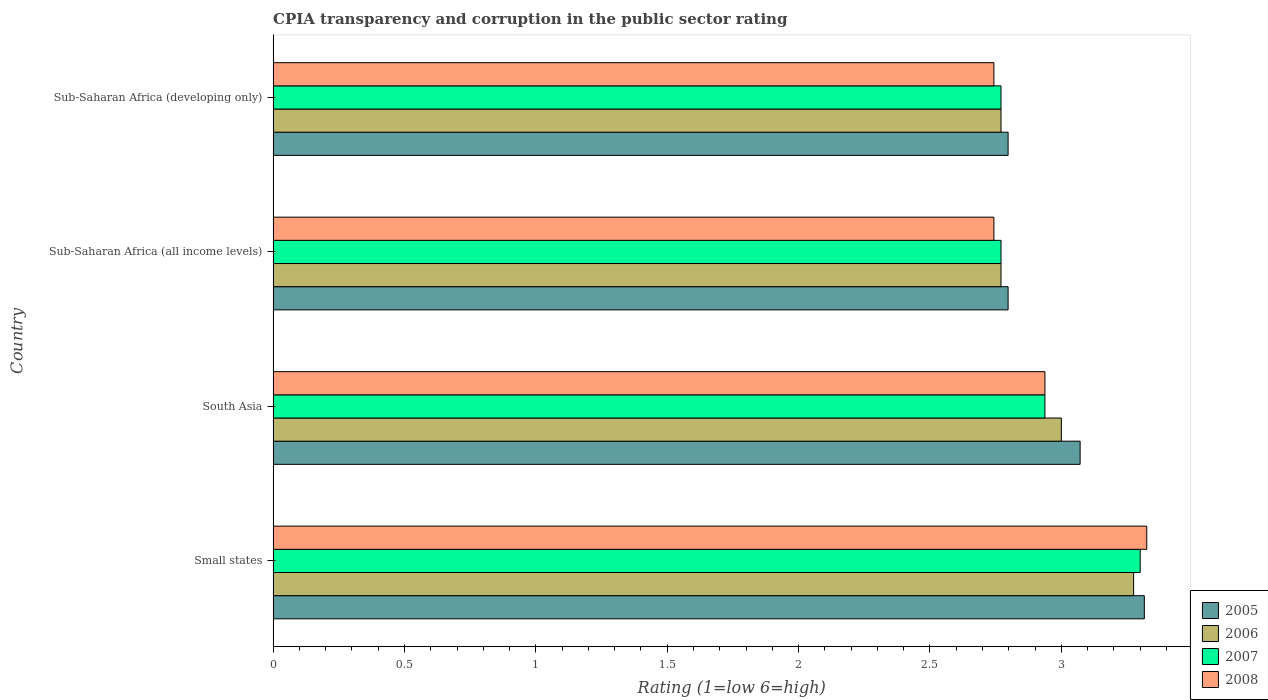Are the number of bars per tick equal to the number of legend labels?
Your answer should be very brief. Yes. How many bars are there on the 1st tick from the top?
Keep it short and to the point. 4. How many bars are there on the 3rd tick from the bottom?
Keep it short and to the point. 4. In how many cases, is the number of bars for a given country not equal to the number of legend labels?
Ensure brevity in your answer.  0. What is the CPIA rating in 2008 in Sub-Saharan Africa (developing only)?
Keep it short and to the point. 2.74. Across all countries, what is the minimum CPIA rating in 2007?
Provide a succinct answer. 2.77. In which country was the CPIA rating in 2005 maximum?
Your answer should be compact. Small states. In which country was the CPIA rating in 2008 minimum?
Ensure brevity in your answer.  Sub-Saharan Africa (all income levels). What is the total CPIA rating in 2005 in the graph?
Keep it short and to the point. 11.98. What is the difference between the CPIA rating in 2007 in Small states and that in Sub-Saharan Africa (all income levels)?
Provide a succinct answer. 0.53. What is the difference between the CPIA rating in 2006 in Sub-Saharan Africa (developing only) and the CPIA rating in 2007 in Small states?
Your answer should be very brief. -0.53. What is the average CPIA rating in 2008 per country?
Your answer should be compact. 2.94. What is the difference between the CPIA rating in 2007 and CPIA rating in 2005 in Sub-Saharan Africa (all income levels)?
Provide a short and direct response. -0.03. In how many countries, is the CPIA rating in 2005 greater than 3 ?
Make the answer very short. 2. What is the ratio of the CPIA rating in 2005 in South Asia to that in Sub-Saharan Africa (all income levels)?
Make the answer very short. 1.1. Is the CPIA rating in 2007 in Small states less than that in Sub-Saharan Africa (all income levels)?
Give a very brief answer. No. What is the difference between the highest and the second highest CPIA rating in 2007?
Offer a very short reply. 0.36. What is the difference between the highest and the lowest CPIA rating in 2007?
Keep it short and to the point. 0.53. In how many countries, is the CPIA rating in 2007 greater than the average CPIA rating in 2007 taken over all countries?
Provide a succinct answer. 1. Is the sum of the CPIA rating in 2005 in South Asia and Sub-Saharan Africa (developing only) greater than the maximum CPIA rating in 2007 across all countries?
Keep it short and to the point. Yes. Is it the case that in every country, the sum of the CPIA rating in 2007 and CPIA rating in 2008 is greater than the sum of CPIA rating in 2006 and CPIA rating in 2005?
Keep it short and to the point. No. What does the 3rd bar from the top in Sub-Saharan Africa (developing only) represents?
Your response must be concise. 2006. What does the 4th bar from the bottom in Small states represents?
Provide a succinct answer. 2008. Are all the bars in the graph horizontal?
Provide a succinct answer. Yes. How many countries are there in the graph?
Provide a short and direct response. 4. What is the difference between two consecutive major ticks on the X-axis?
Keep it short and to the point. 0.5. Where does the legend appear in the graph?
Your answer should be very brief. Bottom right. How many legend labels are there?
Ensure brevity in your answer.  4. What is the title of the graph?
Offer a terse response. CPIA transparency and corruption in the public sector rating. What is the Rating (1=low 6=high) of 2005 in Small states?
Offer a very short reply. 3.32. What is the Rating (1=low 6=high) in 2006 in Small states?
Your answer should be very brief. 3.27. What is the Rating (1=low 6=high) in 2007 in Small states?
Make the answer very short. 3.3. What is the Rating (1=low 6=high) of 2008 in Small states?
Your answer should be compact. 3.33. What is the Rating (1=low 6=high) in 2005 in South Asia?
Provide a short and direct response. 3.07. What is the Rating (1=low 6=high) in 2006 in South Asia?
Your answer should be very brief. 3. What is the Rating (1=low 6=high) in 2007 in South Asia?
Your response must be concise. 2.94. What is the Rating (1=low 6=high) of 2008 in South Asia?
Your answer should be very brief. 2.94. What is the Rating (1=low 6=high) of 2005 in Sub-Saharan Africa (all income levels)?
Give a very brief answer. 2.8. What is the Rating (1=low 6=high) of 2006 in Sub-Saharan Africa (all income levels)?
Your answer should be very brief. 2.77. What is the Rating (1=low 6=high) in 2007 in Sub-Saharan Africa (all income levels)?
Ensure brevity in your answer.  2.77. What is the Rating (1=low 6=high) of 2008 in Sub-Saharan Africa (all income levels)?
Keep it short and to the point. 2.74. What is the Rating (1=low 6=high) of 2005 in Sub-Saharan Africa (developing only)?
Ensure brevity in your answer.  2.8. What is the Rating (1=low 6=high) of 2006 in Sub-Saharan Africa (developing only)?
Ensure brevity in your answer.  2.77. What is the Rating (1=low 6=high) of 2007 in Sub-Saharan Africa (developing only)?
Give a very brief answer. 2.77. What is the Rating (1=low 6=high) of 2008 in Sub-Saharan Africa (developing only)?
Offer a terse response. 2.74. Across all countries, what is the maximum Rating (1=low 6=high) in 2005?
Keep it short and to the point. 3.32. Across all countries, what is the maximum Rating (1=low 6=high) in 2006?
Keep it short and to the point. 3.27. Across all countries, what is the maximum Rating (1=low 6=high) of 2008?
Provide a short and direct response. 3.33. Across all countries, what is the minimum Rating (1=low 6=high) of 2005?
Your response must be concise. 2.8. Across all countries, what is the minimum Rating (1=low 6=high) in 2006?
Offer a terse response. 2.77. Across all countries, what is the minimum Rating (1=low 6=high) of 2007?
Offer a very short reply. 2.77. Across all countries, what is the minimum Rating (1=low 6=high) in 2008?
Give a very brief answer. 2.74. What is the total Rating (1=low 6=high) in 2005 in the graph?
Your answer should be compact. 11.98. What is the total Rating (1=low 6=high) in 2006 in the graph?
Your answer should be very brief. 11.82. What is the total Rating (1=low 6=high) in 2007 in the graph?
Offer a very short reply. 11.78. What is the total Rating (1=low 6=high) in 2008 in the graph?
Keep it short and to the point. 11.75. What is the difference between the Rating (1=low 6=high) of 2005 in Small states and that in South Asia?
Keep it short and to the point. 0.24. What is the difference between the Rating (1=low 6=high) of 2006 in Small states and that in South Asia?
Provide a succinct answer. 0.28. What is the difference between the Rating (1=low 6=high) in 2007 in Small states and that in South Asia?
Keep it short and to the point. 0.36. What is the difference between the Rating (1=low 6=high) of 2008 in Small states and that in South Asia?
Your answer should be compact. 0.39. What is the difference between the Rating (1=low 6=high) in 2005 in Small states and that in Sub-Saharan Africa (all income levels)?
Your response must be concise. 0.52. What is the difference between the Rating (1=low 6=high) of 2006 in Small states and that in Sub-Saharan Africa (all income levels)?
Give a very brief answer. 0.5. What is the difference between the Rating (1=low 6=high) of 2007 in Small states and that in Sub-Saharan Africa (all income levels)?
Provide a succinct answer. 0.53. What is the difference between the Rating (1=low 6=high) in 2008 in Small states and that in Sub-Saharan Africa (all income levels)?
Offer a very short reply. 0.58. What is the difference between the Rating (1=low 6=high) of 2005 in Small states and that in Sub-Saharan Africa (developing only)?
Provide a succinct answer. 0.52. What is the difference between the Rating (1=low 6=high) in 2006 in Small states and that in Sub-Saharan Africa (developing only)?
Provide a succinct answer. 0.5. What is the difference between the Rating (1=low 6=high) of 2007 in Small states and that in Sub-Saharan Africa (developing only)?
Give a very brief answer. 0.53. What is the difference between the Rating (1=low 6=high) of 2008 in Small states and that in Sub-Saharan Africa (developing only)?
Make the answer very short. 0.58. What is the difference between the Rating (1=low 6=high) of 2005 in South Asia and that in Sub-Saharan Africa (all income levels)?
Your answer should be compact. 0.27. What is the difference between the Rating (1=low 6=high) in 2006 in South Asia and that in Sub-Saharan Africa (all income levels)?
Offer a very short reply. 0.23. What is the difference between the Rating (1=low 6=high) in 2007 in South Asia and that in Sub-Saharan Africa (all income levels)?
Make the answer very short. 0.17. What is the difference between the Rating (1=low 6=high) of 2008 in South Asia and that in Sub-Saharan Africa (all income levels)?
Make the answer very short. 0.19. What is the difference between the Rating (1=low 6=high) in 2005 in South Asia and that in Sub-Saharan Africa (developing only)?
Your answer should be very brief. 0.27. What is the difference between the Rating (1=low 6=high) in 2006 in South Asia and that in Sub-Saharan Africa (developing only)?
Ensure brevity in your answer.  0.23. What is the difference between the Rating (1=low 6=high) in 2007 in South Asia and that in Sub-Saharan Africa (developing only)?
Ensure brevity in your answer.  0.17. What is the difference between the Rating (1=low 6=high) in 2008 in South Asia and that in Sub-Saharan Africa (developing only)?
Ensure brevity in your answer.  0.19. What is the difference between the Rating (1=low 6=high) in 2005 in Sub-Saharan Africa (all income levels) and that in Sub-Saharan Africa (developing only)?
Offer a terse response. 0. What is the difference between the Rating (1=low 6=high) of 2006 in Sub-Saharan Africa (all income levels) and that in Sub-Saharan Africa (developing only)?
Your answer should be compact. 0. What is the difference between the Rating (1=low 6=high) in 2007 in Sub-Saharan Africa (all income levels) and that in Sub-Saharan Africa (developing only)?
Your answer should be compact. 0. What is the difference between the Rating (1=low 6=high) of 2005 in Small states and the Rating (1=low 6=high) of 2006 in South Asia?
Offer a terse response. 0.32. What is the difference between the Rating (1=low 6=high) in 2005 in Small states and the Rating (1=low 6=high) in 2007 in South Asia?
Ensure brevity in your answer.  0.38. What is the difference between the Rating (1=low 6=high) of 2005 in Small states and the Rating (1=low 6=high) of 2008 in South Asia?
Keep it short and to the point. 0.38. What is the difference between the Rating (1=low 6=high) in 2006 in Small states and the Rating (1=low 6=high) in 2007 in South Asia?
Offer a terse response. 0.34. What is the difference between the Rating (1=low 6=high) of 2006 in Small states and the Rating (1=low 6=high) of 2008 in South Asia?
Your answer should be very brief. 0.34. What is the difference between the Rating (1=low 6=high) of 2007 in Small states and the Rating (1=low 6=high) of 2008 in South Asia?
Your response must be concise. 0.36. What is the difference between the Rating (1=low 6=high) of 2005 in Small states and the Rating (1=low 6=high) of 2006 in Sub-Saharan Africa (all income levels)?
Ensure brevity in your answer.  0.55. What is the difference between the Rating (1=low 6=high) of 2005 in Small states and the Rating (1=low 6=high) of 2007 in Sub-Saharan Africa (all income levels)?
Your answer should be compact. 0.55. What is the difference between the Rating (1=low 6=high) in 2005 in Small states and the Rating (1=low 6=high) in 2008 in Sub-Saharan Africa (all income levels)?
Make the answer very short. 0.57. What is the difference between the Rating (1=low 6=high) in 2006 in Small states and the Rating (1=low 6=high) in 2007 in Sub-Saharan Africa (all income levels)?
Provide a succinct answer. 0.5. What is the difference between the Rating (1=low 6=high) of 2006 in Small states and the Rating (1=low 6=high) of 2008 in Sub-Saharan Africa (all income levels)?
Keep it short and to the point. 0.53. What is the difference between the Rating (1=low 6=high) of 2007 in Small states and the Rating (1=low 6=high) of 2008 in Sub-Saharan Africa (all income levels)?
Offer a terse response. 0.56. What is the difference between the Rating (1=low 6=high) in 2005 in Small states and the Rating (1=low 6=high) in 2006 in Sub-Saharan Africa (developing only)?
Your response must be concise. 0.55. What is the difference between the Rating (1=low 6=high) of 2005 in Small states and the Rating (1=low 6=high) of 2007 in Sub-Saharan Africa (developing only)?
Your answer should be compact. 0.55. What is the difference between the Rating (1=low 6=high) in 2005 in Small states and the Rating (1=low 6=high) in 2008 in Sub-Saharan Africa (developing only)?
Your answer should be compact. 0.57. What is the difference between the Rating (1=low 6=high) in 2006 in Small states and the Rating (1=low 6=high) in 2007 in Sub-Saharan Africa (developing only)?
Keep it short and to the point. 0.5. What is the difference between the Rating (1=low 6=high) of 2006 in Small states and the Rating (1=low 6=high) of 2008 in Sub-Saharan Africa (developing only)?
Keep it short and to the point. 0.53. What is the difference between the Rating (1=low 6=high) in 2007 in Small states and the Rating (1=low 6=high) in 2008 in Sub-Saharan Africa (developing only)?
Give a very brief answer. 0.56. What is the difference between the Rating (1=low 6=high) of 2005 in South Asia and the Rating (1=low 6=high) of 2006 in Sub-Saharan Africa (all income levels)?
Keep it short and to the point. 0.3. What is the difference between the Rating (1=low 6=high) in 2005 in South Asia and the Rating (1=low 6=high) in 2007 in Sub-Saharan Africa (all income levels)?
Provide a succinct answer. 0.3. What is the difference between the Rating (1=low 6=high) of 2005 in South Asia and the Rating (1=low 6=high) of 2008 in Sub-Saharan Africa (all income levels)?
Your response must be concise. 0.33. What is the difference between the Rating (1=low 6=high) in 2006 in South Asia and the Rating (1=low 6=high) in 2007 in Sub-Saharan Africa (all income levels)?
Your answer should be very brief. 0.23. What is the difference between the Rating (1=low 6=high) in 2006 in South Asia and the Rating (1=low 6=high) in 2008 in Sub-Saharan Africa (all income levels)?
Your answer should be compact. 0.26. What is the difference between the Rating (1=low 6=high) in 2007 in South Asia and the Rating (1=low 6=high) in 2008 in Sub-Saharan Africa (all income levels)?
Ensure brevity in your answer.  0.19. What is the difference between the Rating (1=low 6=high) in 2005 in South Asia and the Rating (1=low 6=high) in 2006 in Sub-Saharan Africa (developing only)?
Provide a succinct answer. 0.3. What is the difference between the Rating (1=low 6=high) of 2005 in South Asia and the Rating (1=low 6=high) of 2007 in Sub-Saharan Africa (developing only)?
Provide a short and direct response. 0.3. What is the difference between the Rating (1=low 6=high) of 2005 in South Asia and the Rating (1=low 6=high) of 2008 in Sub-Saharan Africa (developing only)?
Provide a short and direct response. 0.33. What is the difference between the Rating (1=low 6=high) in 2006 in South Asia and the Rating (1=low 6=high) in 2007 in Sub-Saharan Africa (developing only)?
Your answer should be compact. 0.23. What is the difference between the Rating (1=low 6=high) of 2006 in South Asia and the Rating (1=low 6=high) of 2008 in Sub-Saharan Africa (developing only)?
Offer a terse response. 0.26. What is the difference between the Rating (1=low 6=high) in 2007 in South Asia and the Rating (1=low 6=high) in 2008 in Sub-Saharan Africa (developing only)?
Your answer should be very brief. 0.19. What is the difference between the Rating (1=low 6=high) of 2005 in Sub-Saharan Africa (all income levels) and the Rating (1=low 6=high) of 2006 in Sub-Saharan Africa (developing only)?
Your response must be concise. 0.03. What is the difference between the Rating (1=low 6=high) of 2005 in Sub-Saharan Africa (all income levels) and the Rating (1=low 6=high) of 2007 in Sub-Saharan Africa (developing only)?
Offer a terse response. 0.03. What is the difference between the Rating (1=low 6=high) in 2005 in Sub-Saharan Africa (all income levels) and the Rating (1=low 6=high) in 2008 in Sub-Saharan Africa (developing only)?
Give a very brief answer. 0.05. What is the difference between the Rating (1=low 6=high) in 2006 in Sub-Saharan Africa (all income levels) and the Rating (1=low 6=high) in 2008 in Sub-Saharan Africa (developing only)?
Provide a succinct answer. 0.03. What is the difference between the Rating (1=low 6=high) in 2007 in Sub-Saharan Africa (all income levels) and the Rating (1=low 6=high) in 2008 in Sub-Saharan Africa (developing only)?
Keep it short and to the point. 0.03. What is the average Rating (1=low 6=high) of 2005 per country?
Your answer should be very brief. 3. What is the average Rating (1=low 6=high) in 2006 per country?
Offer a very short reply. 2.95. What is the average Rating (1=low 6=high) in 2007 per country?
Provide a short and direct response. 2.94. What is the average Rating (1=low 6=high) in 2008 per country?
Provide a succinct answer. 2.94. What is the difference between the Rating (1=low 6=high) in 2005 and Rating (1=low 6=high) in 2006 in Small states?
Ensure brevity in your answer.  0.04. What is the difference between the Rating (1=low 6=high) in 2005 and Rating (1=low 6=high) in 2007 in Small states?
Your response must be concise. 0.02. What is the difference between the Rating (1=low 6=high) in 2005 and Rating (1=low 6=high) in 2008 in Small states?
Make the answer very short. -0.01. What is the difference between the Rating (1=low 6=high) in 2006 and Rating (1=low 6=high) in 2007 in Small states?
Your response must be concise. -0.03. What is the difference between the Rating (1=low 6=high) in 2006 and Rating (1=low 6=high) in 2008 in Small states?
Offer a very short reply. -0.05. What is the difference between the Rating (1=low 6=high) in 2007 and Rating (1=low 6=high) in 2008 in Small states?
Provide a succinct answer. -0.03. What is the difference between the Rating (1=low 6=high) of 2005 and Rating (1=low 6=high) of 2006 in South Asia?
Give a very brief answer. 0.07. What is the difference between the Rating (1=low 6=high) in 2005 and Rating (1=low 6=high) in 2007 in South Asia?
Provide a short and direct response. 0.13. What is the difference between the Rating (1=low 6=high) of 2005 and Rating (1=low 6=high) of 2008 in South Asia?
Provide a short and direct response. 0.13. What is the difference between the Rating (1=low 6=high) in 2006 and Rating (1=low 6=high) in 2007 in South Asia?
Your answer should be compact. 0.06. What is the difference between the Rating (1=low 6=high) of 2006 and Rating (1=low 6=high) of 2008 in South Asia?
Your answer should be very brief. 0.06. What is the difference between the Rating (1=low 6=high) in 2005 and Rating (1=low 6=high) in 2006 in Sub-Saharan Africa (all income levels)?
Give a very brief answer. 0.03. What is the difference between the Rating (1=low 6=high) of 2005 and Rating (1=low 6=high) of 2007 in Sub-Saharan Africa (all income levels)?
Make the answer very short. 0.03. What is the difference between the Rating (1=low 6=high) in 2005 and Rating (1=low 6=high) in 2008 in Sub-Saharan Africa (all income levels)?
Your answer should be compact. 0.05. What is the difference between the Rating (1=low 6=high) of 2006 and Rating (1=low 6=high) of 2007 in Sub-Saharan Africa (all income levels)?
Offer a terse response. 0. What is the difference between the Rating (1=low 6=high) of 2006 and Rating (1=low 6=high) of 2008 in Sub-Saharan Africa (all income levels)?
Keep it short and to the point. 0.03. What is the difference between the Rating (1=low 6=high) in 2007 and Rating (1=low 6=high) in 2008 in Sub-Saharan Africa (all income levels)?
Offer a very short reply. 0.03. What is the difference between the Rating (1=low 6=high) of 2005 and Rating (1=low 6=high) of 2006 in Sub-Saharan Africa (developing only)?
Your answer should be compact. 0.03. What is the difference between the Rating (1=low 6=high) in 2005 and Rating (1=low 6=high) in 2007 in Sub-Saharan Africa (developing only)?
Offer a terse response. 0.03. What is the difference between the Rating (1=low 6=high) of 2005 and Rating (1=low 6=high) of 2008 in Sub-Saharan Africa (developing only)?
Your answer should be very brief. 0.05. What is the difference between the Rating (1=low 6=high) in 2006 and Rating (1=low 6=high) in 2007 in Sub-Saharan Africa (developing only)?
Your response must be concise. 0. What is the difference between the Rating (1=low 6=high) of 2006 and Rating (1=low 6=high) of 2008 in Sub-Saharan Africa (developing only)?
Offer a terse response. 0.03. What is the difference between the Rating (1=low 6=high) of 2007 and Rating (1=low 6=high) of 2008 in Sub-Saharan Africa (developing only)?
Offer a very short reply. 0.03. What is the ratio of the Rating (1=low 6=high) of 2005 in Small states to that in South Asia?
Provide a succinct answer. 1.08. What is the ratio of the Rating (1=low 6=high) of 2006 in Small states to that in South Asia?
Give a very brief answer. 1.09. What is the ratio of the Rating (1=low 6=high) in 2007 in Small states to that in South Asia?
Your answer should be very brief. 1.12. What is the ratio of the Rating (1=low 6=high) of 2008 in Small states to that in South Asia?
Offer a terse response. 1.13. What is the ratio of the Rating (1=low 6=high) of 2005 in Small states to that in Sub-Saharan Africa (all income levels)?
Your response must be concise. 1.19. What is the ratio of the Rating (1=low 6=high) in 2006 in Small states to that in Sub-Saharan Africa (all income levels)?
Keep it short and to the point. 1.18. What is the ratio of the Rating (1=low 6=high) of 2007 in Small states to that in Sub-Saharan Africa (all income levels)?
Offer a terse response. 1.19. What is the ratio of the Rating (1=low 6=high) of 2008 in Small states to that in Sub-Saharan Africa (all income levels)?
Keep it short and to the point. 1.21. What is the ratio of the Rating (1=low 6=high) in 2005 in Small states to that in Sub-Saharan Africa (developing only)?
Your answer should be very brief. 1.19. What is the ratio of the Rating (1=low 6=high) of 2006 in Small states to that in Sub-Saharan Africa (developing only)?
Your answer should be very brief. 1.18. What is the ratio of the Rating (1=low 6=high) in 2007 in Small states to that in Sub-Saharan Africa (developing only)?
Your response must be concise. 1.19. What is the ratio of the Rating (1=low 6=high) in 2008 in Small states to that in Sub-Saharan Africa (developing only)?
Ensure brevity in your answer.  1.21. What is the ratio of the Rating (1=low 6=high) of 2005 in South Asia to that in Sub-Saharan Africa (all income levels)?
Offer a terse response. 1.1. What is the ratio of the Rating (1=low 6=high) in 2006 in South Asia to that in Sub-Saharan Africa (all income levels)?
Your answer should be very brief. 1.08. What is the ratio of the Rating (1=low 6=high) in 2007 in South Asia to that in Sub-Saharan Africa (all income levels)?
Ensure brevity in your answer.  1.06. What is the ratio of the Rating (1=low 6=high) of 2008 in South Asia to that in Sub-Saharan Africa (all income levels)?
Keep it short and to the point. 1.07. What is the ratio of the Rating (1=low 6=high) in 2005 in South Asia to that in Sub-Saharan Africa (developing only)?
Provide a short and direct response. 1.1. What is the ratio of the Rating (1=low 6=high) of 2006 in South Asia to that in Sub-Saharan Africa (developing only)?
Make the answer very short. 1.08. What is the ratio of the Rating (1=low 6=high) of 2007 in South Asia to that in Sub-Saharan Africa (developing only)?
Ensure brevity in your answer.  1.06. What is the ratio of the Rating (1=low 6=high) of 2008 in South Asia to that in Sub-Saharan Africa (developing only)?
Ensure brevity in your answer.  1.07. What is the ratio of the Rating (1=low 6=high) in 2005 in Sub-Saharan Africa (all income levels) to that in Sub-Saharan Africa (developing only)?
Provide a succinct answer. 1. What is the ratio of the Rating (1=low 6=high) in 2007 in Sub-Saharan Africa (all income levels) to that in Sub-Saharan Africa (developing only)?
Give a very brief answer. 1. What is the difference between the highest and the second highest Rating (1=low 6=high) in 2005?
Your response must be concise. 0.24. What is the difference between the highest and the second highest Rating (1=low 6=high) in 2006?
Ensure brevity in your answer.  0.28. What is the difference between the highest and the second highest Rating (1=low 6=high) in 2007?
Your answer should be very brief. 0.36. What is the difference between the highest and the second highest Rating (1=low 6=high) in 2008?
Your answer should be very brief. 0.39. What is the difference between the highest and the lowest Rating (1=low 6=high) of 2005?
Your response must be concise. 0.52. What is the difference between the highest and the lowest Rating (1=low 6=high) of 2006?
Provide a short and direct response. 0.5. What is the difference between the highest and the lowest Rating (1=low 6=high) of 2007?
Your answer should be compact. 0.53. What is the difference between the highest and the lowest Rating (1=low 6=high) of 2008?
Your answer should be very brief. 0.58. 